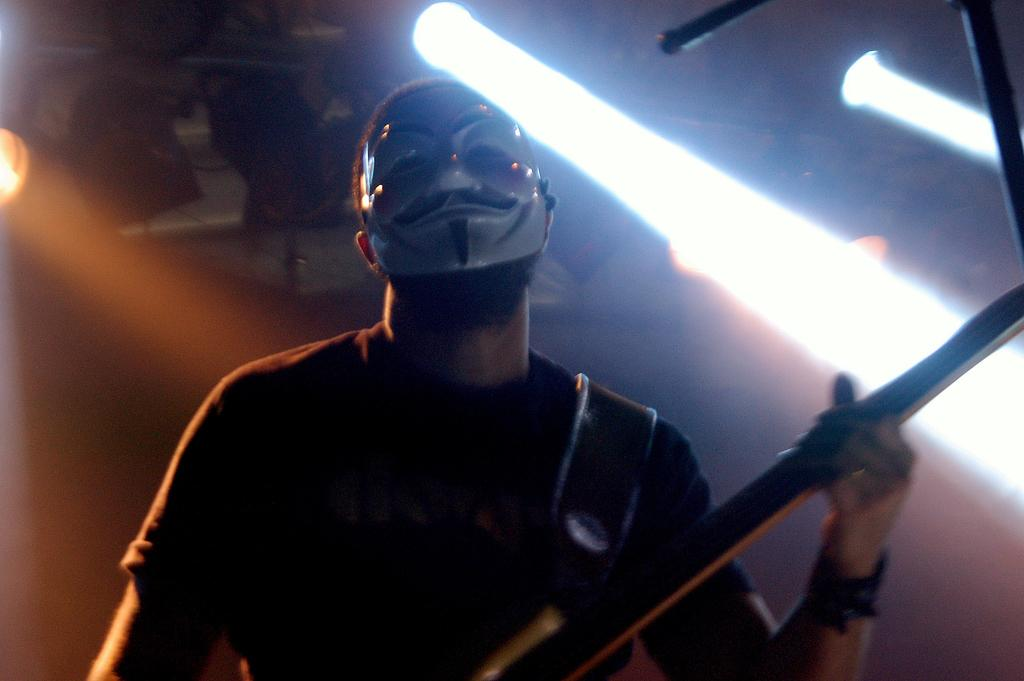What is the person in the image doing? The person in the image is playing a musical instrument. What is the person wearing on their face? The person is wearing a mask. How many dogs are participating in the musical competition in the image? There are no dogs or musical competition present in the image. What type of wire is being used to connect the musical instrument to the amplifier in the image? There is no wire or amplifier visible in the image. 